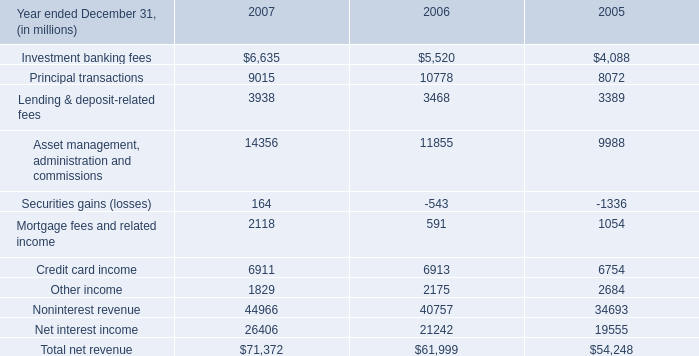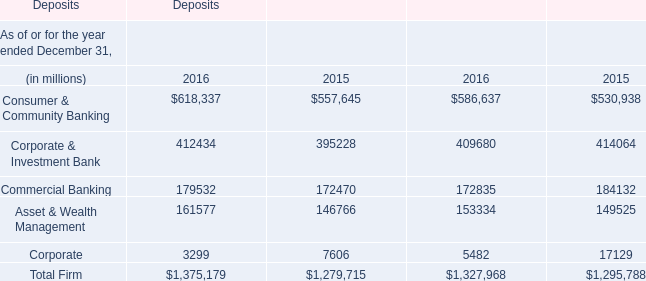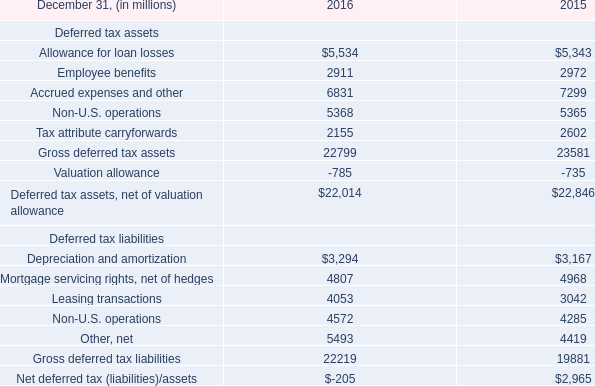what was the percentage change in investment banking fees from 2005 to 2006? 
Computations: ((5520 - 4088) / 4088)
Answer: 0.35029. 